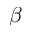Convert formula to latex. <formula><loc_0><loc_0><loc_500><loc_500>\beta</formula> 